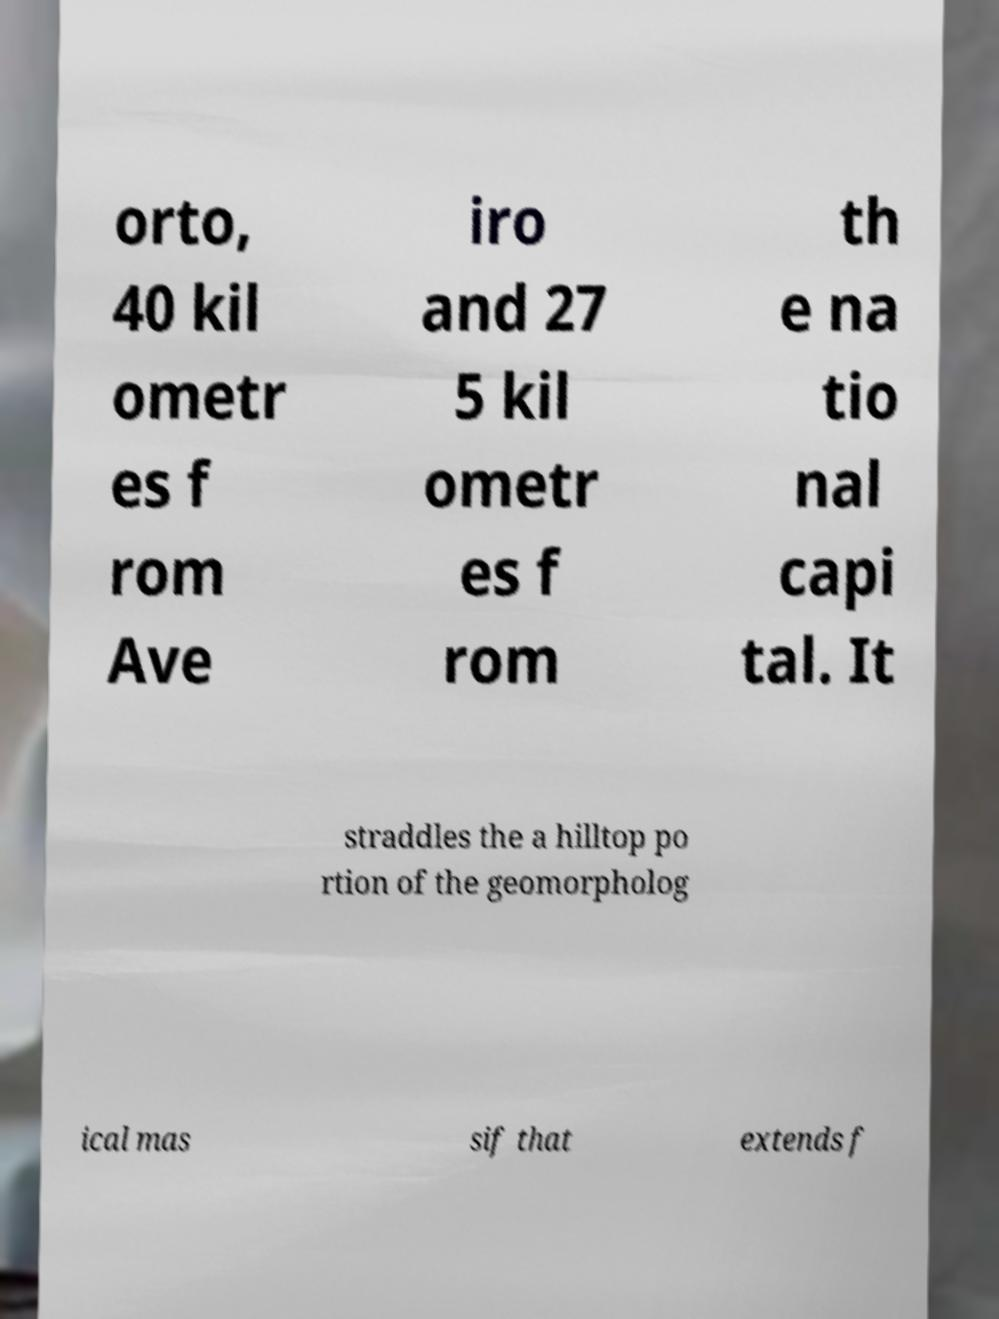Please read and relay the text visible in this image. What does it say? orto, 40 kil ometr es f rom Ave iro and 27 5 kil ometr es f rom th e na tio nal capi tal. It straddles the a hilltop po rtion of the geomorpholog ical mas sif that extends f 